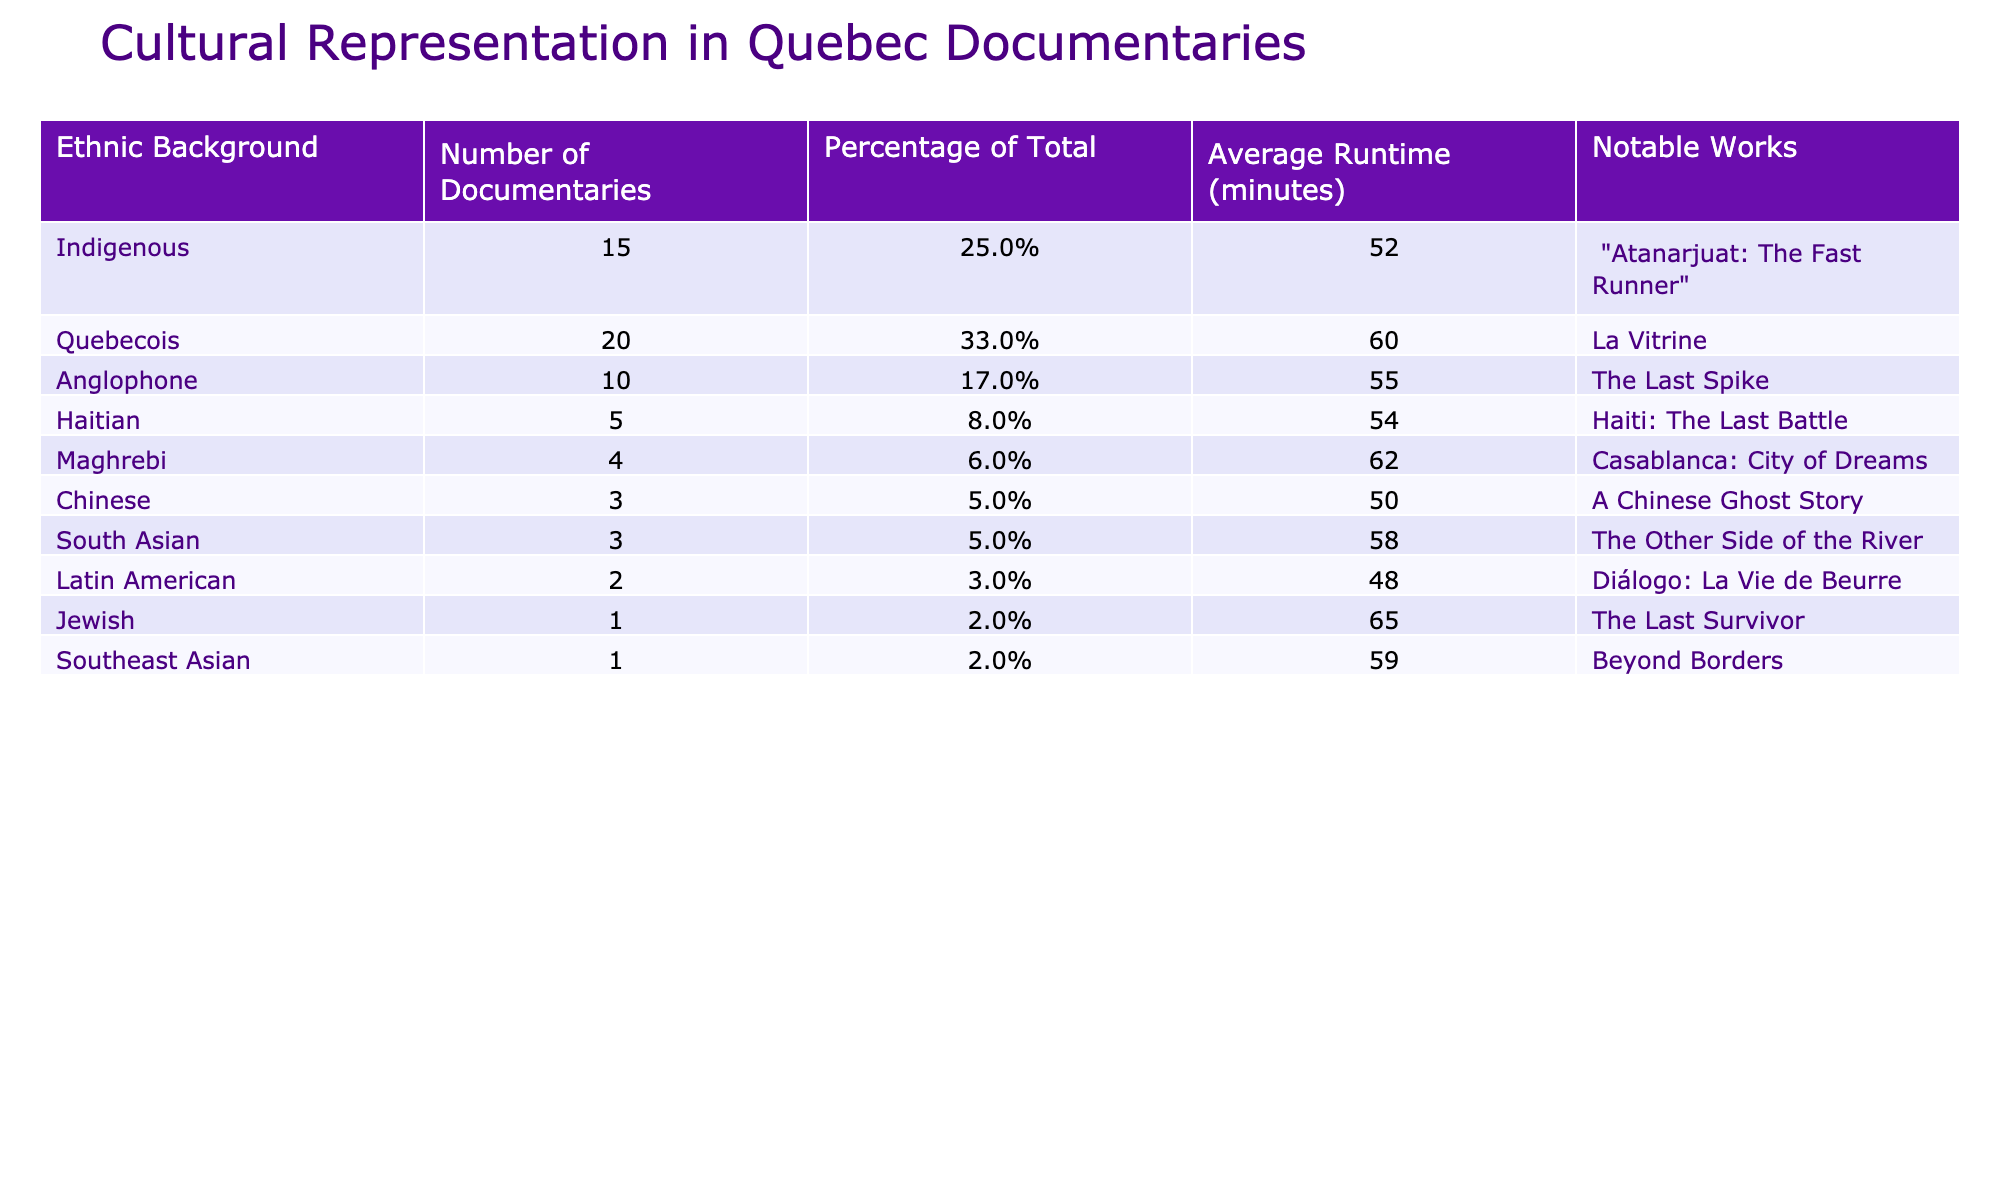What is the percentage of total documentaries that feature Quebecois narratives? The table shows that the number of documentaries featuring Quebecois narratives is 20. The total number of documentaries in the table can be calculated as the sum of all documentaries: 15 + 20 + 10 + 5 + 4 + 3 + 3 + 2 + 1 + 1 = 64. The percentage for Quebecois is then (20/64) * 100% = 33%.
Answer: 33% How many documentaries feature a South Asian perspective? According to the table, the number of documentaries featuring a South Asian perspective is listed directly as 3.
Answer: 3 What is the average runtime of documentaries that represent Jewish stories? From the table, the average runtime of the documentary representative of Jewish stories is noted as 65 minutes.
Answer: 65 minutes What is the total number of documentaries that represent Indigenous and Anglophone backgrounds combined? The total number of documentaries for Indigenous is 15 and for Anglophone is 10. Adding these together gives: 15 + 10 = 25.
Answer: 25 Is the average runtime of Haitian documentaries longer than that of Chinese documentaries? The average runtime for Haitian documentaries is mentioned as 54 minutes, while for Chinese it is 50 minutes. Since 54 > 50, the answer is yes.
Answer: Yes What is the median runtime of documentaries across all ethnic backgrounds? To find the median, we first need to list the average runtimes in order: 48, 50, 52, 54, 55, 58, 59, 60, 62, 65. There are 10 values (even number), so the median is the average of the 5th and 6th values in the ordered list, which are 55 and 58. Thus, the median is (55 + 58)/2 = 56.5.
Answer: 56.5 Which ethnic background has the least representation in terms of the number of documentaries? The table shows that the ethnic background with the least documentaries is Jewish, with only 1 documentary.
Answer: Jewish What is the difference in the number of documentaries between the group with the highest representation and the one with the lowest? The group with the highest representation is Quebecois (20 documentaries) and the lowest is Jewish (1 documentary). The difference is calculated as 20 - 1 = 19.
Answer: 19 Are there more Indigenous documentaries than there are Latin American documentaries? Indigenous documentaries number 15, while Latin American documentaries number 2. Since 15 > 2, the answer is yes.
Answer: Yes If we combine the documentaries representing Maghrebi and Southeast Asian backgrounds, what percentage of the total does that represent? The number of Maghrebi documentaries is 4 and Southeast Asian is 1, totaling 4 + 1 = 5. Thus, the percentage of total is (5/64) * 100% = 7.81%, which rounds to 7.8%.
Answer: 7.8% 